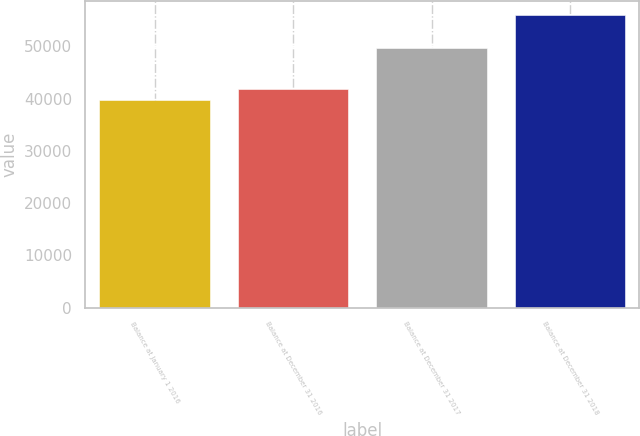Convert chart to OTSL. <chart><loc_0><loc_0><loc_500><loc_500><bar_chart><fcel>Balance at January 1 2016<fcel>Balance at December 31 2016<fcel>Balance at December 31 2017<fcel>Balance at December 31 2018<nl><fcel>39657<fcel>41754<fcel>49618<fcel>55941<nl></chart> 